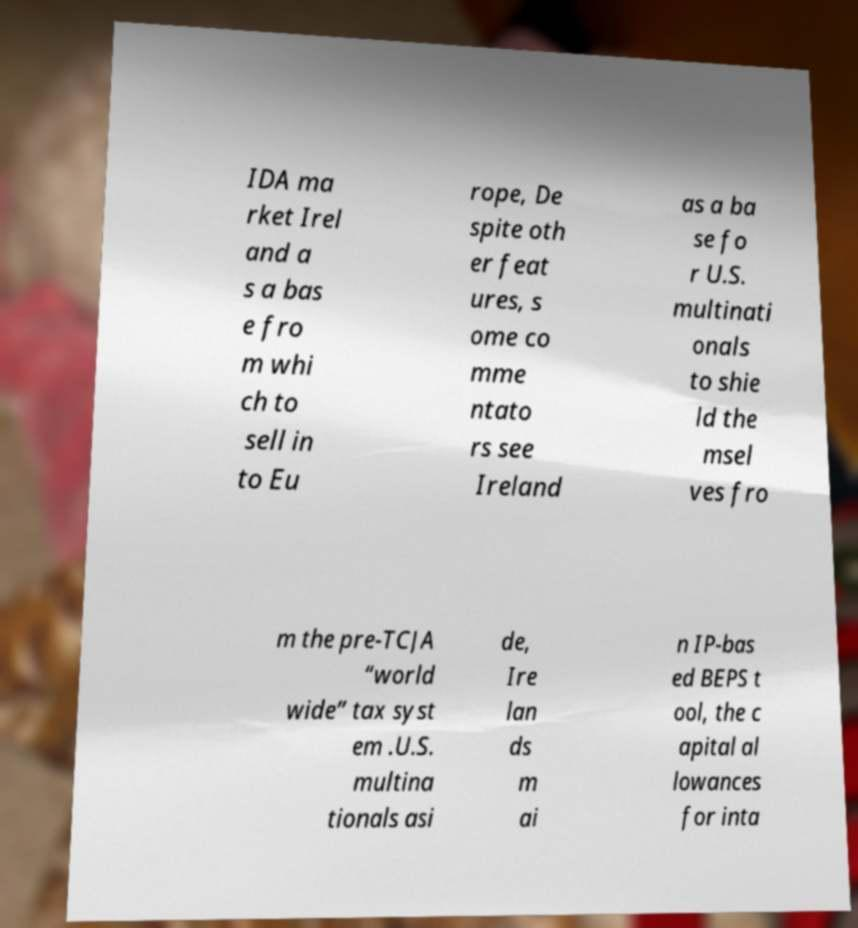There's text embedded in this image that I need extracted. Can you transcribe it verbatim? IDA ma rket Irel and a s a bas e fro m whi ch to sell in to Eu rope, De spite oth er feat ures, s ome co mme ntato rs see Ireland as a ba se fo r U.S. multinati onals to shie ld the msel ves fro m the pre-TCJA “world wide” tax syst em .U.S. multina tionals asi de, Ire lan ds m ai n IP-bas ed BEPS t ool, the c apital al lowances for inta 